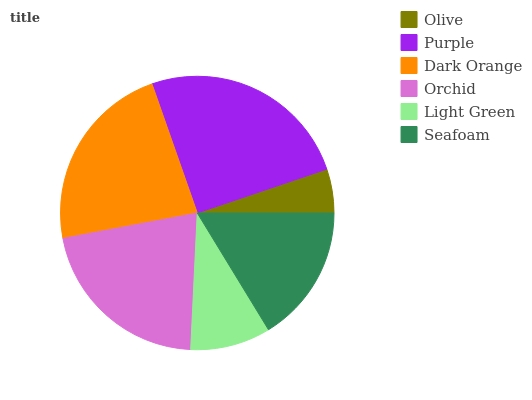Is Olive the minimum?
Answer yes or no. Yes. Is Purple the maximum?
Answer yes or no. Yes. Is Dark Orange the minimum?
Answer yes or no. No. Is Dark Orange the maximum?
Answer yes or no. No. Is Purple greater than Dark Orange?
Answer yes or no. Yes. Is Dark Orange less than Purple?
Answer yes or no. Yes. Is Dark Orange greater than Purple?
Answer yes or no. No. Is Purple less than Dark Orange?
Answer yes or no. No. Is Orchid the high median?
Answer yes or no. Yes. Is Seafoam the low median?
Answer yes or no. Yes. Is Purple the high median?
Answer yes or no. No. Is Purple the low median?
Answer yes or no. No. 